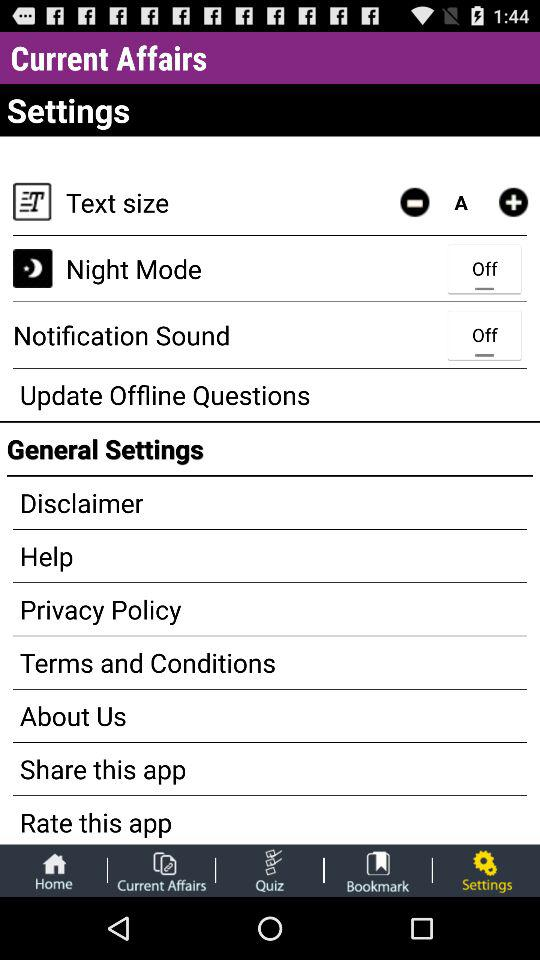What is the setting for notification sound? The setting for notification sound is "off". 